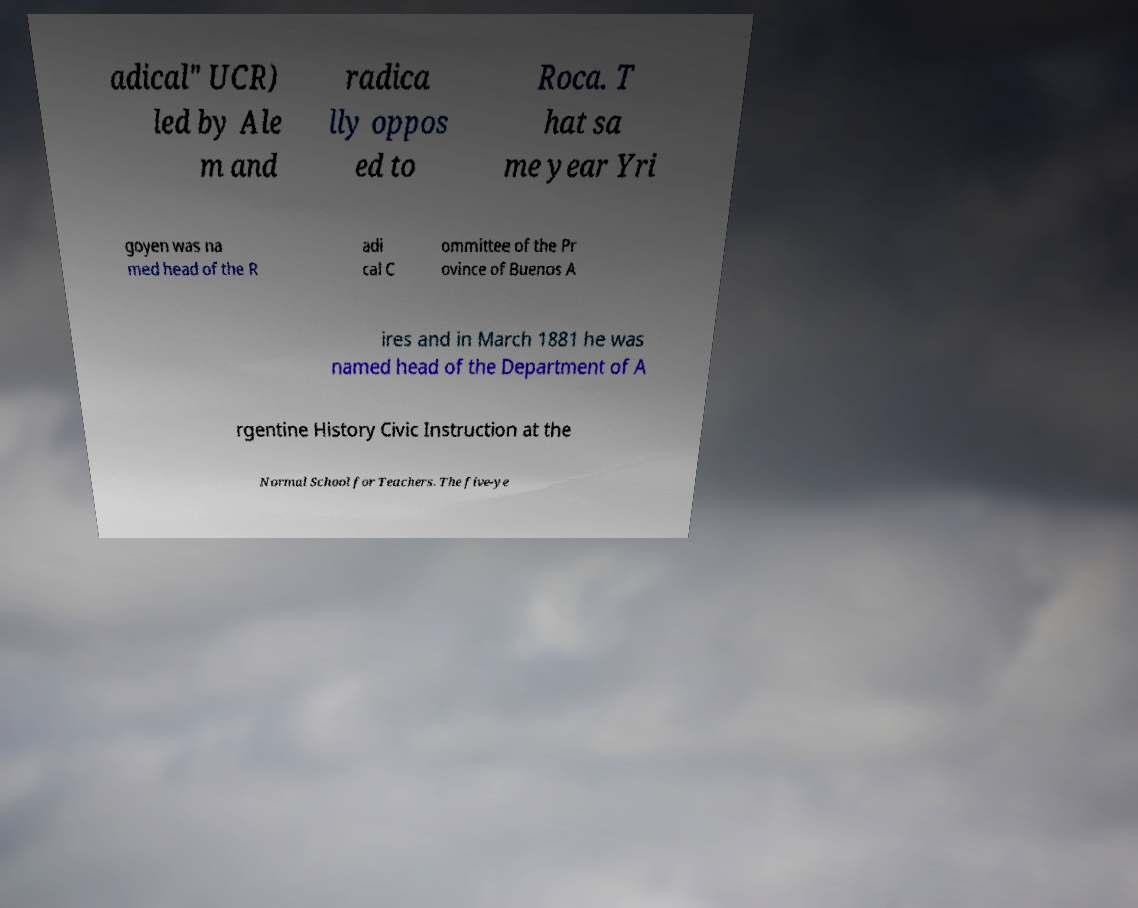For documentation purposes, I need the text within this image transcribed. Could you provide that? adical" UCR) led by Ale m and radica lly oppos ed to Roca. T hat sa me year Yri goyen was na med head of the R adi cal C ommittee of the Pr ovince of Buenos A ires and in March 1881 he was named head of the Department of A rgentine History Civic Instruction at the Normal School for Teachers. The five-ye 